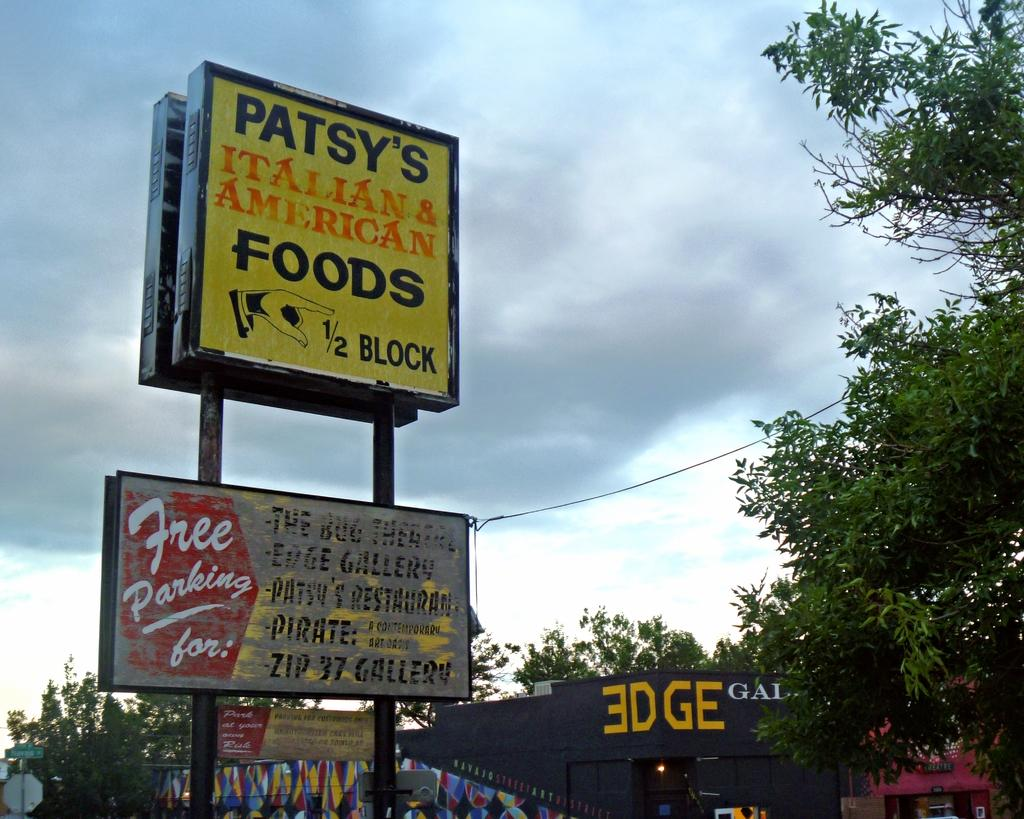<image>
Write a terse but informative summary of the picture. A sign in yellow for Patsy's Italian ans American Foods. 